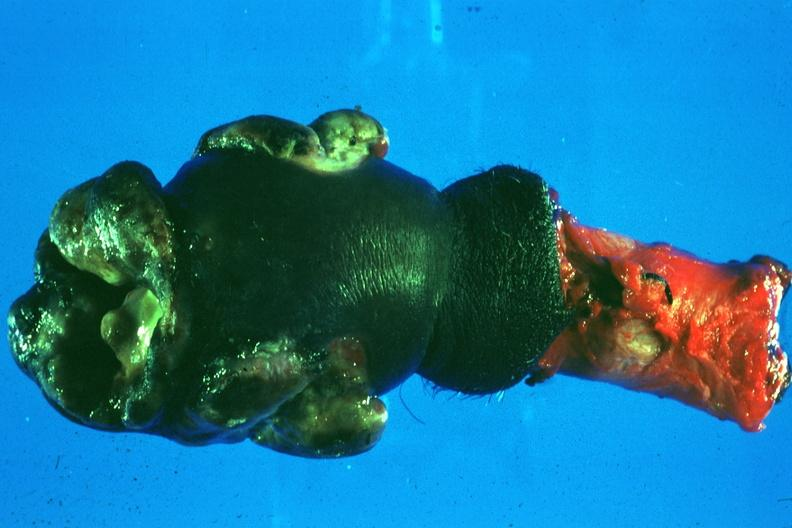what does this image show?
Answer the question using a single word or phrase. Excised penis with nodular masses of tumor 